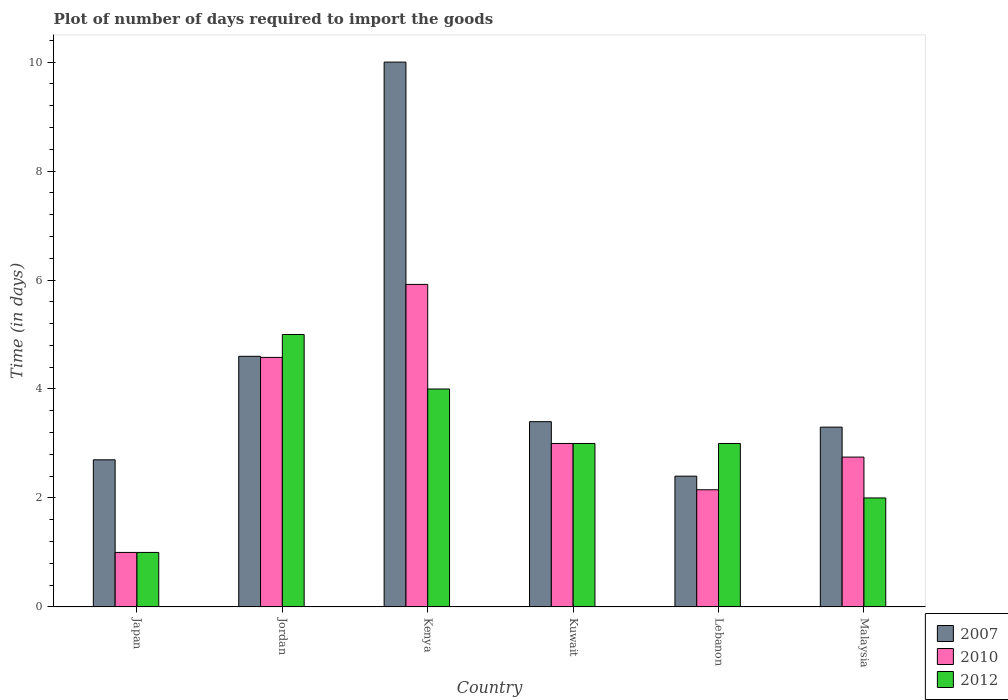Are the number of bars on each tick of the X-axis equal?
Make the answer very short. Yes. How many bars are there on the 4th tick from the left?
Your response must be concise. 3. How many bars are there on the 4th tick from the right?
Make the answer very short. 3. What is the label of the 2nd group of bars from the left?
Your response must be concise. Jordan. Across all countries, what is the maximum time required to import goods in 2010?
Offer a very short reply. 5.92. In which country was the time required to import goods in 2007 maximum?
Keep it short and to the point. Kenya. What is the total time required to import goods in 2012 in the graph?
Give a very brief answer. 18. What is the difference between the time required to import goods in 2012 in Jordan and that in Lebanon?
Give a very brief answer. 2. What is the difference between the time required to import goods in 2010 in Kenya and the time required to import goods in 2012 in Japan?
Keep it short and to the point. 4.92. What is the average time required to import goods in 2007 per country?
Offer a terse response. 4.4. What is the difference between the time required to import goods of/in 2007 and time required to import goods of/in 2012 in Japan?
Offer a terse response. 1.7. What is the ratio of the time required to import goods in 2012 in Japan to that in Kuwait?
Make the answer very short. 0.33. Is the difference between the time required to import goods in 2007 in Kenya and Kuwait greater than the difference between the time required to import goods in 2012 in Kenya and Kuwait?
Offer a very short reply. Yes. What is the difference between the highest and the lowest time required to import goods in 2010?
Keep it short and to the point. 4.92. What does the 2nd bar from the left in Malaysia represents?
Your response must be concise. 2010. Is it the case that in every country, the sum of the time required to import goods in 2010 and time required to import goods in 2007 is greater than the time required to import goods in 2012?
Provide a short and direct response. Yes. Are all the bars in the graph horizontal?
Make the answer very short. No. How many countries are there in the graph?
Provide a short and direct response. 6. Does the graph contain any zero values?
Offer a very short reply. No. Does the graph contain grids?
Your response must be concise. No. How are the legend labels stacked?
Provide a short and direct response. Vertical. What is the title of the graph?
Give a very brief answer. Plot of number of days required to import the goods. What is the label or title of the X-axis?
Your answer should be compact. Country. What is the label or title of the Y-axis?
Give a very brief answer. Time (in days). What is the Time (in days) in 2007 in Japan?
Your response must be concise. 2.7. What is the Time (in days) of 2010 in Japan?
Keep it short and to the point. 1. What is the Time (in days) of 2012 in Japan?
Offer a terse response. 1. What is the Time (in days) in 2007 in Jordan?
Your answer should be very brief. 4.6. What is the Time (in days) of 2010 in Jordan?
Make the answer very short. 4.58. What is the Time (in days) of 2007 in Kenya?
Offer a very short reply. 10. What is the Time (in days) in 2010 in Kenya?
Offer a terse response. 5.92. What is the Time (in days) in 2012 in Kenya?
Give a very brief answer. 4. What is the Time (in days) in 2007 in Kuwait?
Offer a very short reply. 3.4. What is the Time (in days) of 2012 in Kuwait?
Your answer should be compact. 3. What is the Time (in days) in 2007 in Lebanon?
Offer a terse response. 2.4. What is the Time (in days) of 2010 in Lebanon?
Offer a very short reply. 2.15. What is the Time (in days) of 2010 in Malaysia?
Your answer should be compact. 2.75. What is the Time (in days) of 2012 in Malaysia?
Ensure brevity in your answer.  2. Across all countries, what is the maximum Time (in days) of 2007?
Keep it short and to the point. 10. Across all countries, what is the maximum Time (in days) in 2010?
Keep it short and to the point. 5.92. Across all countries, what is the maximum Time (in days) of 2012?
Your answer should be compact. 5. Across all countries, what is the minimum Time (in days) in 2007?
Your response must be concise. 2.4. Across all countries, what is the minimum Time (in days) in 2010?
Give a very brief answer. 1. What is the total Time (in days) of 2007 in the graph?
Offer a very short reply. 26.4. What is the total Time (in days) in 2010 in the graph?
Provide a short and direct response. 19.4. What is the difference between the Time (in days) in 2007 in Japan and that in Jordan?
Keep it short and to the point. -1.9. What is the difference between the Time (in days) of 2010 in Japan and that in Jordan?
Offer a very short reply. -3.58. What is the difference between the Time (in days) in 2012 in Japan and that in Jordan?
Ensure brevity in your answer.  -4. What is the difference between the Time (in days) of 2007 in Japan and that in Kenya?
Your response must be concise. -7.3. What is the difference between the Time (in days) in 2010 in Japan and that in Kenya?
Provide a succinct answer. -4.92. What is the difference between the Time (in days) in 2010 in Japan and that in Kuwait?
Offer a very short reply. -2. What is the difference between the Time (in days) of 2010 in Japan and that in Lebanon?
Your answer should be very brief. -1.15. What is the difference between the Time (in days) of 2012 in Japan and that in Lebanon?
Your answer should be compact. -2. What is the difference between the Time (in days) of 2010 in Japan and that in Malaysia?
Offer a very short reply. -1.75. What is the difference between the Time (in days) in 2007 in Jordan and that in Kenya?
Keep it short and to the point. -5.4. What is the difference between the Time (in days) in 2010 in Jordan and that in Kenya?
Your response must be concise. -1.34. What is the difference between the Time (in days) in 2012 in Jordan and that in Kenya?
Your answer should be compact. 1. What is the difference between the Time (in days) in 2010 in Jordan and that in Kuwait?
Offer a terse response. 1.58. What is the difference between the Time (in days) of 2007 in Jordan and that in Lebanon?
Provide a short and direct response. 2.2. What is the difference between the Time (in days) of 2010 in Jordan and that in Lebanon?
Ensure brevity in your answer.  2.43. What is the difference between the Time (in days) in 2010 in Jordan and that in Malaysia?
Give a very brief answer. 1.83. What is the difference between the Time (in days) in 2012 in Jordan and that in Malaysia?
Your response must be concise. 3. What is the difference between the Time (in days) of 2007 in Kenya and that in Kuwait?
Offer a terse response. 6.6. What is the difference between the Time (in days) in 2010 in Kenya and that in Kuwait?
Your answer should be compact. 2.92. What is the difference between the Time (in days) of 2010 in Kenya and that in Lebanon?
Offer a terse response. 3.77. What is the difference between the Time (in days) of 2007 in Kenya and that in Malaysia?
Keep it short and to the point. 6.7. What is the difference between the Time (in days) of 2010 in Kenya and that in Malaysia?
Make the answer very short. 3.17. What is the difference between the Time (in days) in 2012 in Kenya and that in Malaysia?
Provide a short and direct response. 2. What is the difference between the Time (in days) in 2012 in Kuwait and that in Lebanon?
Provide a succinct answer. 0. What is the difference between the Time (in days) of 2007 in Kuwait and that in Malaysia?
Provide a succinct answer. 0.1. What is the difference between the Time (in days) in 2012 in Kuwait and that in Malaysia?
Provide a succinct answer. 1. What is the difference between the Time (in days) in 2007 in Lebanon and that in Malaysia?
Provide a short and direct response. -0.9. What is the difference between the Time (in days) in 2010 in Lebanon and that in Malaysia?
Your response must be concise. -0.6. What is the difference between the Time (in days) of 2012 in Lebanon and that in Malaysia?
Provide a short and direct response. 1. What is the difference between the Time (in days) of 2007 in Japan and the Time (in days) of 2010 in Jordan?
Provide a short and direct response. -1.88. What is the difference between the Time (in days) of 2010 in Japan and the Time (in days) of 2012 in Jordan?
Ensure brevity in your answer.  -4. What is the difference between the Time (in days) of 2007 in Japan and the Time (in days) of 2010 in Kenya?
Give a very brief answer. -3.22. What is the difference between the Time (in days) in 2007 in Japan and the Time (in days) in 2012 in Kenya?
Make the answer very short. -1.3. What is the difference between the Time (in days) of 2007 in Japan and the Time (in days) of 2012 in Kuwait?
Your answer should be very brief. -0.3. What is the difference between the Time (in days) in 2010 in Japan and the Time (in days) in 2012 in Kuwait?
Offer a very short reply. -2. What is the difference between the Time (in days) in 2007 in Japan and the Time (in days) in 2010 in Lebanon?
Your response must be concise. 0.55. What is the difference between the Time (in days) of 2007 in Japan and the Time (in days) of 2012 in Lebanon?
Provide a short and direct response. -0.3. What is the difference between the Time (in days) in 2007 in Japan and the Time (in days) in 2010 in Malaysia?
Keep it short and to the point. -0.05. What is the difference between the Time (in days) of 2007 in Japan and the Time (in days) of 2012 in Malaysia?
Ensure brevity in your answer.  0.7. What is the difference between the Time (in days) of 2007 in Jordan and the Time (in days) of 2010 in Kenya?
Your answer should be compact. -1.32. What is the difference between the Time (in days) of 2010 in Jordan and the Time (in days) of 2012 in Kenya?
Offer a terse response. 0.58. What is the difference between the Time (in days) in 2010 in Jordan and the Time (in days) in 2012 in Kuwait?
Ensure brevity in your answer.  1.58. What is the difference between the Time (in days) of 2007 in Jordan and the Time (in days) of 2010 in Lebanon?
Make the answer very short. 2.45. What is the difference between the Time (in days) of 2007 in Jordan and the Time (in days) of 2012 in Lebanon?
Your answer should be very brief. 1.6. What is the difference between the Time (in days) of 2010 in Jordan and the Time (in days) of 2012 in Lebanon?
Provide a short and direct response. 1.58. What is the difference between the Time (in days) in 2007 in Jordan and the Time (in days) in 2010 in Malaysia?
Your answer should be very brief. 1.85. What is the difference between the Time (in days) of 2010 in Jordan and the Time (in days) of 2012 in Malaysia?
Offer a terse response. 2.58. What is the difference between the Time (in days) in 2010 in Kenya and the Time (in days) in 2012 in Kuwait?
Make the answer very short. 2.92. What is the difference between the Time (in days) in 2007 in Kenya and the Time (in days) in 2010 in Lebanon?
Offer a terse response. 7.85. What is the difference between the Time (in days) in 2007 in Kenya and the Time (in days) in 2012 in Lebanon?
Offer a very short reply. 7. What is the difference between the Time (in days) in 2010 in Kenya and the Time (in days) in 2012 in Lebanon?
Provide a succinct answer. 2.92. What is the difference between the Time (in days) in 2007 in Kenya and the Time (in days) in 2010 in Malaysia?
Provide a short and direct response. 7.25. What is the difference between the Time (in days) of 2007 in Kenya and the Time (in days) of 2012 in Malaysia?
Offer a very short reply. 8. What is the difference between the Time (in days) of 2010 in Kenya and the Time (in days) of 2012 in Malaysia?
Your response must be concise. 3.92. What is the difference between the Time (in days) in 2007 in Kuwait and the Time (in days) in 2010 in Malaysia?
Make the answer very short. 0.65. What is the difference between the Time (in days) in 2007 in Lebanon and the Time (in days) in 2010 in Malaysia?
Your answer should be very brief. -0.35. What is the difference between the Time (in days) of 2010 in Lebanon and the Time (in days) of 2012 in Malaysia?
Make the answer very short. 0.15. What is the average Time (in days) of 2007 per country?
Your answer should be compact. 4.4. What is the average Time (in days) of 2010 per country?
Provide a short and direct response. 3.23. What is the difference between the Time (in days) of 2007 and Time (in days) of 2012 in Japan?
Give a very brief answer. 1.7. What is the difference between the Time (in days) of 2007 and Time (in days) of 2012 in Jordan?
Your answer should be very brief. -0.4. What is the difference between the Time (in days) of 2010 and Time (in days) of 2012 in Jordan?
Your answer should be compact. -0.42. What is the difference between the Time (in days) of 2007 and Time (in days) of 2010 in Kenya?
Provide a short and direct response. 4.08. What is the difference between the Time (in days) of 2007 and Time (in days) of 2012 in Kenya?
Ensure brevity in your answer.  6. What is the difference between the Time (in days) in 2010 and Time (in days) in 2012 in Kenya?
Ensure brevity in your answer.  1.92. What is the difference between the Time (in days) in 2007 and Time (in days) in 2010 in Kuwait?
Your answer should be very brief. 0.4. What is the difference between the Time (in days) in 2007 and Time (in days) in 2012 in Kuwait?
Your answer should be compact. 0.4. What is the difference between the Time (in days) of 2007 and Time (in days) of 2010 in Lebanon?
Ensure brevity in your answer.  0.25. What is the difference between the Time (in days) of 2007 and Time (in days) of 2012 in Lebanon?
Ensure brevity in your answer.  -0.6. What is the difference between the Time (in days) of 2010 and Time (in days) of 2012 in Lebanon?
Your response must be concise. -0.85. What is the difference between the Time (in days) of 2007 and Time (in days) of 2010 in Malaysia?
Offer a terse response. 0.55. What is the ratio of the Time (in days) of 2007 in Japan to that in Jordan?
Offer a terse response. 0.59. What is the ratio of the Time (in days) of 2010 in Japan to that in Jordan?
Your answer should be very brief. 0.22. What is the ratio of the Time (in days) of 2012 in Japan to that in Jordan?
Your response must be concise. 0.2. What is the ratio of the Time (in days) of 2007 in Japan to that in Kenya?
Your response must be concise. 0.27. What is the ratio of the Time (in days) of 2010 in Japan to that in Kenya?
Make the answer very short. 0.17. What is the ratio of the Time (in days) of 2007 in Japan to that in Kuwait?
Your response must be concise. 0.79. What is the ratio of the Time (in days) of 2010 in Japan to that in Kuwait?
Offer a terse response. 0.33. What is the ratio of the Time (in days) of 2012 in Japan to that in Kuwait?
Provide a succinct answer. 0.33. What is the ratio of the Time (in days) in 2010 in Japan to that in Lebanon?
Provide a succinct answer. 0.47. What is the ratio of the Time (in days) in 2007 in Japan to that in Malaysia?
Keep it short and to the point. 0.82. What is the ratio of the Time (in days) in 2010 in Japan to that in Malaysia?
Make the answer very short. 0.36. What is the ratio of the Time (in days) in 2012 in Japan to that in Malaysia?
Offer a very short reply. 0.5. What is the ratio of the Time (in days) of 2007 in Jordan to that in Kenya?
Ensure brevity in your answer.  0.46. What is the ratio of the Time (in days) in 2010 in Jordan to that in Kenya?
Provide a short and direct response. 0.77. What is the ratio of the Time (in days) of 2007 in Jordan to that in Kuwait?
Your answer should be compact. 1.35. What is the ratio of the Time (in days) of 2010 in Jordan to that in Kuwait?
Offer a terse response. 1.53. What is the ratio of the Time (in days) of 2012 in Jordan to that in Kuwait?
Make the answer very short. 1.67. What is the ratio of the Time (in days) in 2007 in Jordan to that in Lebanon?
Offer a very short reply. 1.92. What is the ratio of the Time (in days) of 2010 in Jordan to that in Lebanon?
Provide a succinct answer. 2.13. What is the ratio of the Time (in days) in 2007 in Jordan to that in Malaysia?
Provide a succinct answer. 1.39. What is the ratio of the Time (in days) of 2010 in Jordan to that in Malaysia?
Offer a terse response. 1.67. What is the ratio of the Time (in days) of 2012 in Jordan to that in Malaysia?
Keep it short and to the point. 2.5. What is the ratio of the Time (in days) of 2007 in Kenya to that in Kuwait?
Offer a very short reply. 2.94. What is the ratio of the Time (in days) in 2010 in Kenya to that in Kuwait?
Make the answer very short. 1.97. What is the ratio of the Time (in days) of 2007 in Kenya to that in Lebanon?
Keep it short and to the point. 4.17. What is the ratio of the Time (in days) of 2010 in Kenya to that in Lebanon?
Your response must be concise. 2.75. What is the ratio of the Time (in days) in 2012 in Kenya to that in Lebanon?
Make the answer very short. 1.33. What is the ratio of the Time (in days) in 2007 in Kenya to that in Malaysia?
Offer a terse response. 3.03. What is the ratio of the Time (in days) in 2010 in Kenya to that in Malaysia?
Provide a short and direct response. 2.15. What is the ratio of the Time (in days) of 2007 in Kuwait to that in Lebanon?
Your response must be concise. 1.42. What is the ratio of the Time (in days) in 2010 in Kuwait to that in Lebanon?
Offer a terse response. 1.4. What is the ratio of the Time (in days) in 2007 in Kuwait to that in Malaysia?
Offer a very short reply. 1.03. What is the ratio of the Time (in days) of 2007 in Lebanon to that in Malaysia?
Offer a very short reply. 0.73. What is the ratio of the Time (in days) of 2010 in Lebanon to that in Malaysia?
Provide a short and direct response. 0.78. What is the difference between the highest and the second highest Time (in days) of 2007?
Your answer should be compact. 5.4. What is the difference between the highest and the second highest Time (in days) of 2010?
Your answer should be very brief. 1.34. What is the difference between the highest and the second highest Time (in days) in 2012?
Offer a very short reply. 1. What is the difference between the highest and the lowest Time (in days) in 2007?
Give a very brief answer. 7.6. What is the difference between the highest and the lowest Time (in days) in 2010?
Give a very brief answer. 4.92. What is the difference between the highest and the lowest Time (in days) of 2012?
Give a very brief answer. 4. 